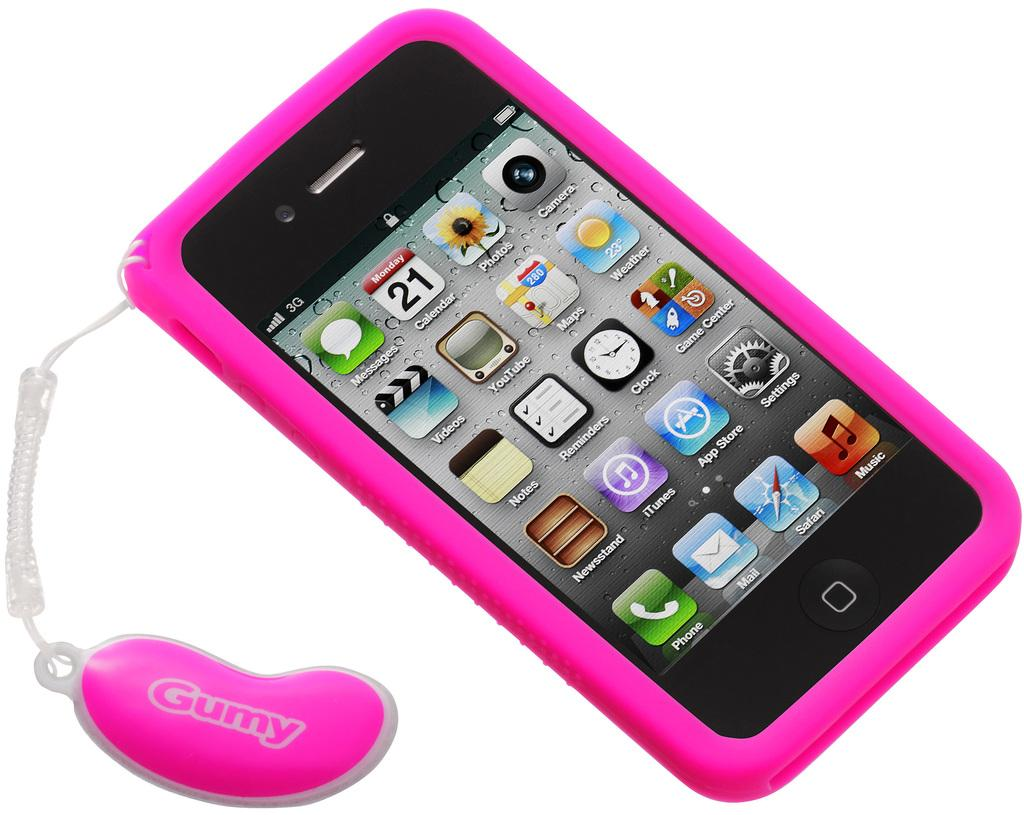<image>
Give a short and clear explanation of the subsequent image. An Apple iPhone has a pink case and a handle attached that says Gumy. 